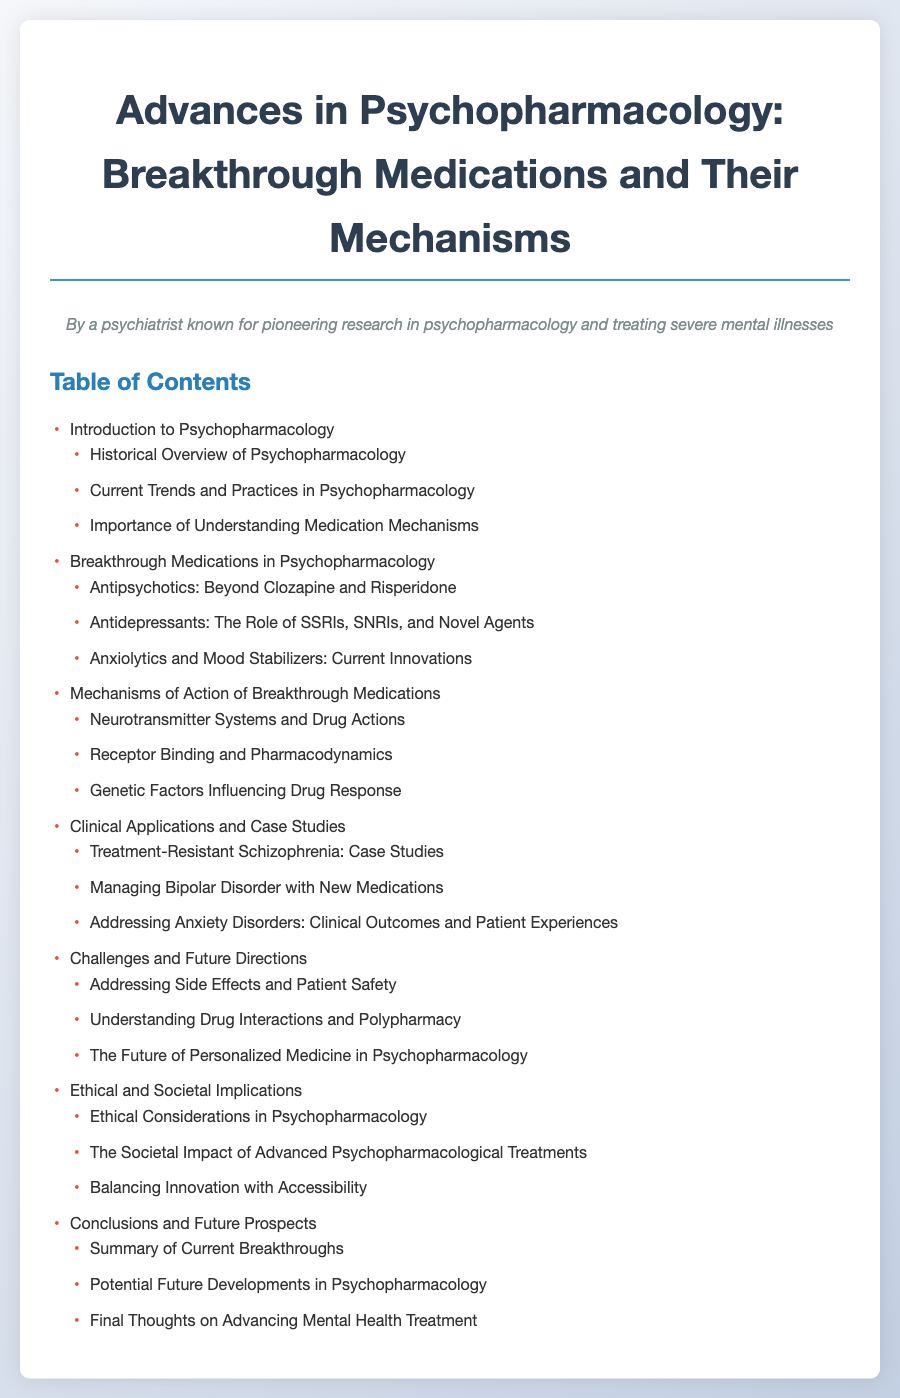What is the first section of the table of contents? The first section listed in the table of contents is "Introduction to Psychopharmacology."
Answer: Introduction to Psychopharmacology How many subsections are under "Breakthrough Medications in Psychopharmacology"? The subsection "Breakthrough Medications in Psychopharmacology" contains three detailed subsections.
Answer: 3 What medication class is discussed after antidepressants in the table of contents? Following the discussion of antidepressants, "Anxiolytics and Mood Stabilizers" is the next topic covered.
Answer: Anxiolytics and Mood Stabilizers What key topic is addressed under "Challenges and Future Directions"? One important topic under "Challenges and Future Directions" concerns managing adverse effects and ensuring safety for patients.
Answer: Addressing Side Effects and Patient Safety What theme is highlighted in the section on "Ethical and Societal Implications"? The section addresses "Ethical Considerations in Psychopharmacology" as a critical theme.
Answer: Ethical Considerations in Psychopharmacology How many case studies are mentioned under "Clinical Applications and Case Studies"? There are three specific case studies referred to in this section.
Answer: 3 What is the last topic listed in the "Conclusions and Future Prospects" section? The final topic mentioned in this section is "Final Thoughts on Advancing Mental Health Treatment."
Answer: Final Thoughts on Advancing Mental Health Treatment What is the purpose of understanding medication mechanisms as stated in the document? The purpose of understanding medication mechanisms is emphasized as important in the context of current practices in psychopharmacology.
Answer: Importance of Understanding Medication Mechanisms 